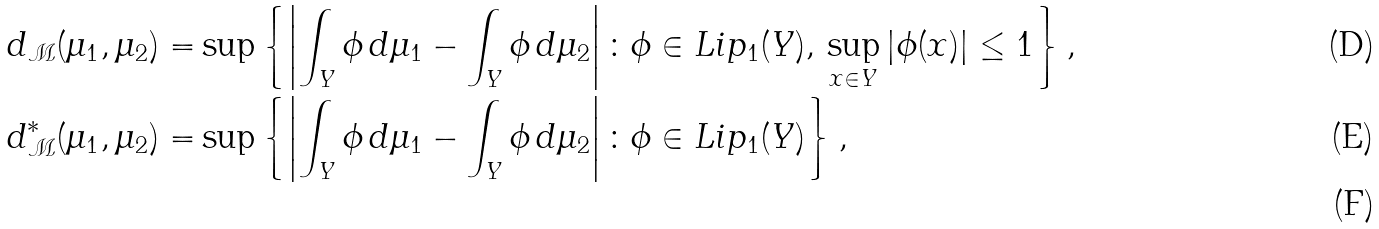<formula> <loc_0><loc_0><loc_500><loc_500>d _ { \mathcal { M } } ( \mu _ { 1 } , \mu _ { 2 } ) = & \sup \left \{ \left | \int _ { Y } \phi \, d \mu _ { 1 } - \int _ { Y } \phi \, d \mu _ { 2 } \right | \colon \phi \in L i p _ { 1 } ( Y ) , \, \sup _ { x \in Y } | \phi ( x ) | \leq 1 \right \} , \\ d _ { \mathcal { M } } ^ { * } ( \mu _ { 1 } , \mu _ { 2 } ) = & \sup \left \{ \left | \int _ { Y } \phi \, d \mu _ { 1 } - \int _ { Y } \phi \, d \mu _ { 2 } \right | \colon \phi \in L i p _ { 1 } ( Y ) \right \} , \\</formula> 